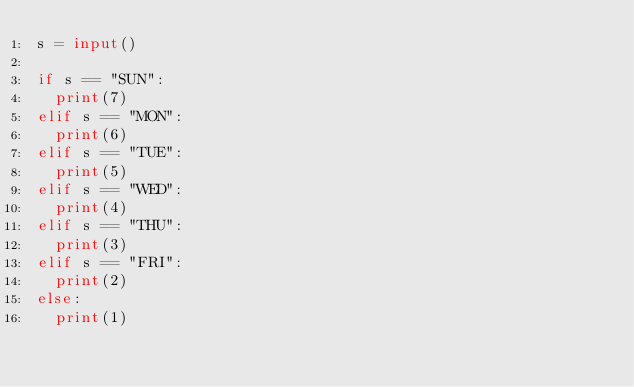<code> <loc_0><loc_0><loc_500><loc_500><_Python_>s = input()

if s == "SUN":
	print(7)
elif s == "MON":
	print(6)
elif s == "TUE":
	print(5)
elif s == "WED":
	print(4)
elif s == "THU":
	print(3)
elif s == "FRI":
	print(2)
else:
	print(1)</code> 